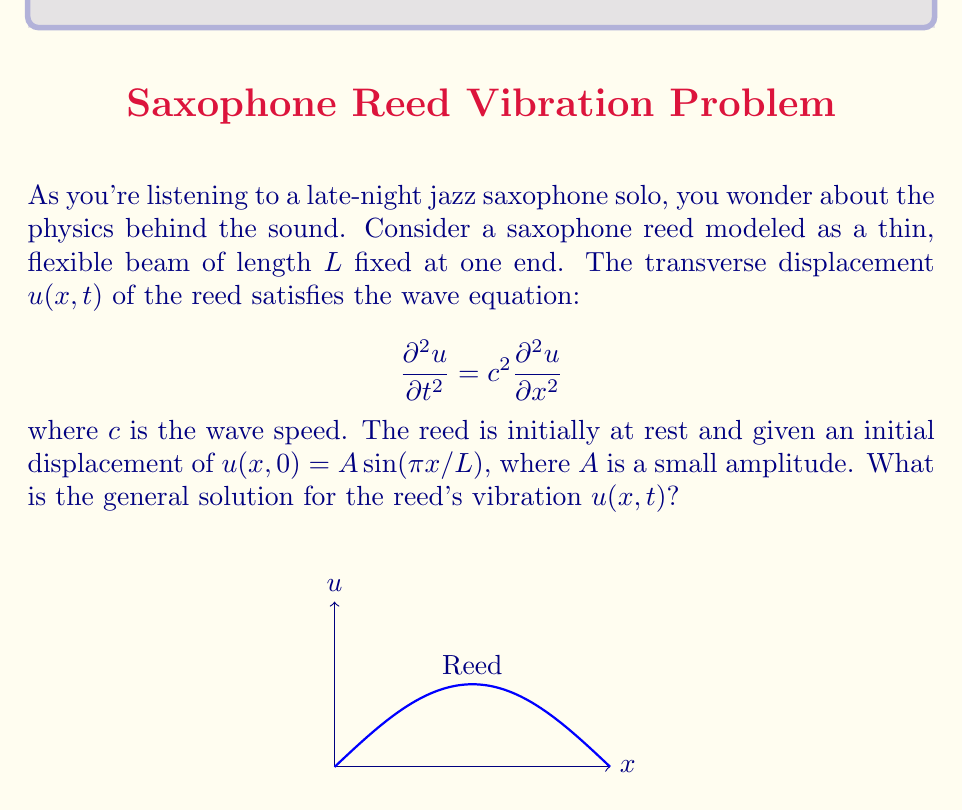Can you solve this math problem? Let's solve this step-by-step:

1) The general solution to the wave equation is of the form:
   $$u(x,t) = X(x)T(t)$$

2) Substituting this into the wave equation:
   $$X(x)T''(t) = c^2X''(x)T(t)$$

3) Separating variables:
   $$\frac{T''(t)}{T(t)} = c^2\frac{X''(x)}{X(x)} = -\omega^2$$

4) This gives us two ordinary differential equations:
   $$T''(t) + \omega^2T(t) = 0$$
   $$X''(x) + \frac{\omega^2}{c^2}X(x) = 0$$

5) The general solutions to these are:
   $$T(t) = A\cos(\omega t) + B\sin(\omega t)$$
   $$X(x) = C\sin(kx) + D\cos(kx)$$
   where $k = \omega/c$

6) The boundary conditions for a reed fixed at one end (x=0) and free at the other (x=L) are:
   $$X(0) = 0 \quad \text{and} \quad X'(L) = 0$$

7) Applying these conditions:
   $$X(x) = C\sin(kx)$$
   $$\cos(kL) = 0$$

8) This gives us the eigenvalues:
   $$k_n = \frac{(2n-1)\pi}{2L}, \quad n = 1,2,3,...$$

9) The corresponding eigenfunctions are:
   $$X_n(x) = \sin(\frac{(2n-1)\pi x}{2L})$$

10) The general solution is a superposition of these modes:
    $$u(x,t) = \sum_{n=1}^{\infty} (A_n\cos(\omega_n t) + B_n\sin(\omega_n t))\sin(\frac{(2n-1)\pi x}{2L})$$
    where $\omega_n = ck_n = \frac{(2n-1)\pi c}{2L}$

11) Given the initial conditions:
    $$u(x,0) = A\sin(\pi x/L), \quad \frac{\partial u}{\partial t}(x,0) = 0$$

12) Comparing with the initial displacement, we see that only the first mode (n=1) is excited:
    $$A_1 = A, \quad B_n = 0 \text{ for all n}, \quad A_n = 0 \text{ for n > 1}$$

Therefore, the solution for the reed's vibration is:
$$u(x,t) = A\cos(\frac{\pi c t}{2L})\sin(\frac{\pi x}{2L})$$
Answer: $u(x,t) = A\cos(\frac{\pi c t}{2L})\sin(\frac{\pi x}{2L})$ 